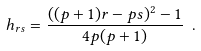<formula> <loc_0><loc_0><loc_500><loc_500>h _ { r s } = \frac { ( ( p + 1 ) r - p s ) ^ { 2 } - 1 } { 4 p ( p + 1 ) } \ .</formula> 